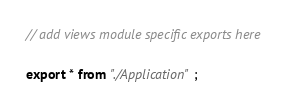Convert code to text. <code><loc_0><loc_0><loc_500><loc_500><_TypeScript_>
// add views module specific exports here

export * from "./Application";</code> 